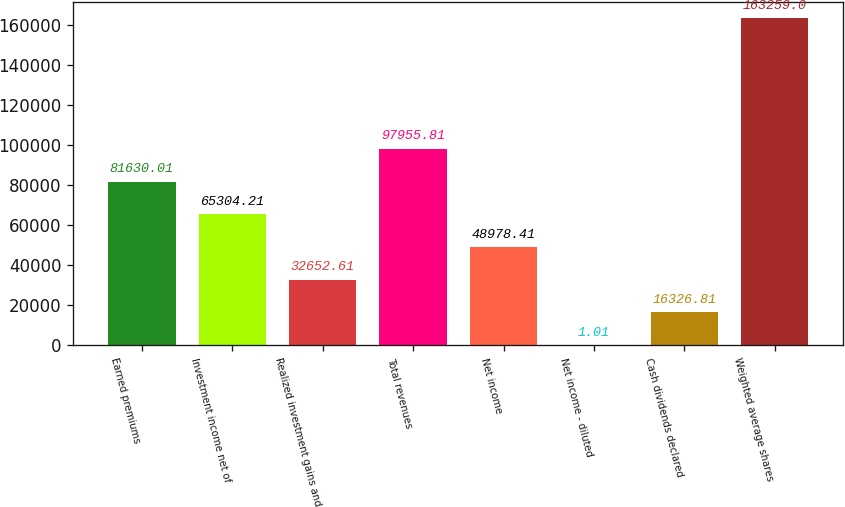Convert chart to OTSL. <chart><loc_0><loc_0><loc_500><loc_500><bar_chart><fcel>Earned premiums<fcel>Investment income net of<fcel>Realized investment gains and<fcel>Total revenues<fcel>Net income<fcel>Net income - diluted<fcel>Cash dividends declared<fcel>Weighted average shares<nl><fcel>81630<fcel>65304.2<fcel>32652.6<fcel>97955.8<fcel>48978.4<fcel>1.01<fcel>16326.8<fcel>163259<nl></chart> 